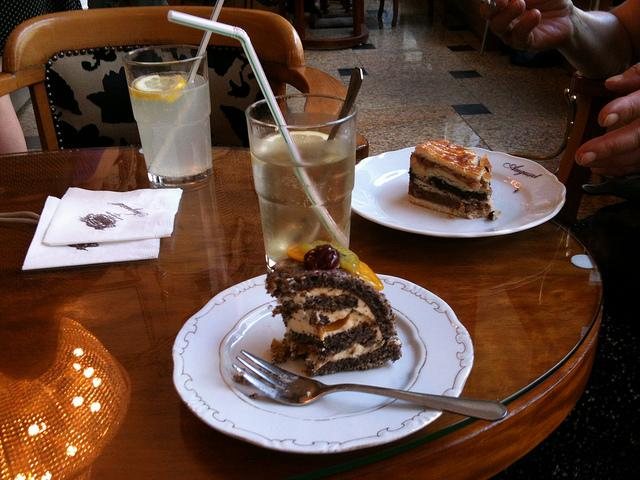How do you say the name of the item on the plate next to the cake in Italian? Please explain your reasoning. forchetta. The italian word for fork is forchetta. 